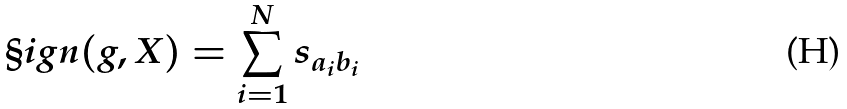Convert formula to latex. <formula><loc_0><loc_0><loc_500><loc_500>\S i g n ( g , X ) = \sum _ { i = 1 } ^ { N } s _ { a _ { i } b _ { i } }</formula> 